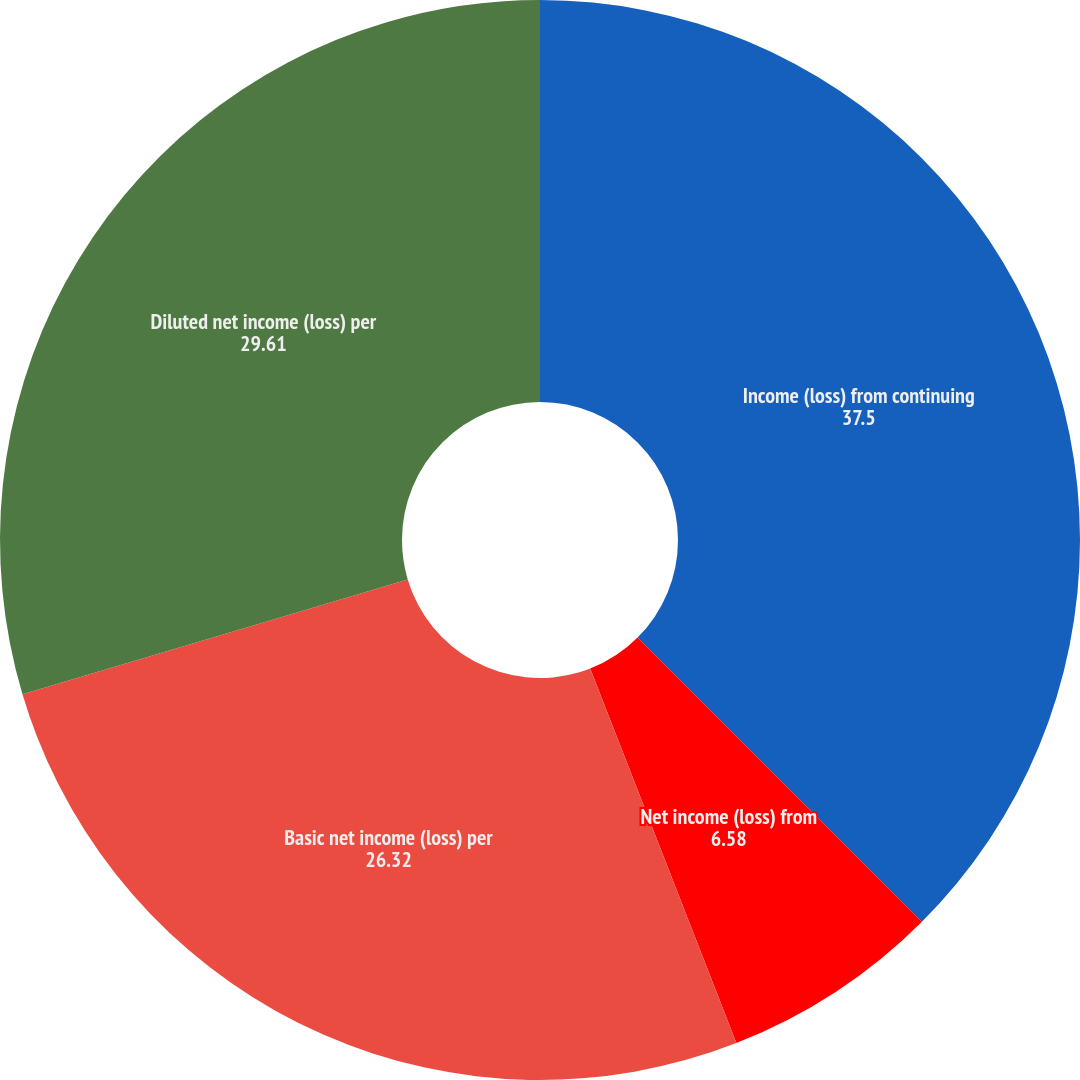Convert chart to OTSL. <chart><loc_0><loc_0><loc_500><loc_500><pie_chart><fcel>Income (loss) from continuing<fcel>Net income (loss) from<fcel>Basic net income (loss) per<fcel>Diluted net income (loss) per<nl><fcel>37.5%<fcel>6.58%<fcel>26.32%<fcel>29.61%<nl></chart> 